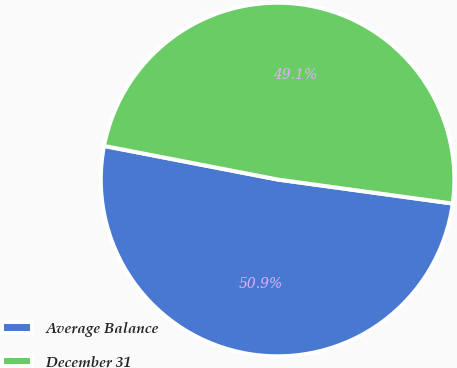<chart> <loc_0><loc_0><loc_500><loc_500><pie_chart><fcel>Average Balance<fcel>December 31<nl><fcel>50.87%<fcel>49.13%<nl></chart> 